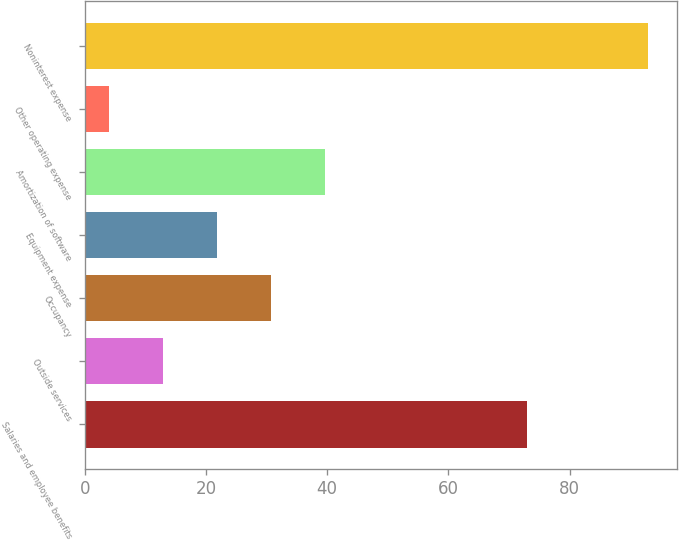Convert chart to OTSL. <chart><loc_0><loc_0><loc_500><loc_500><bar_chart><fcel>Salaries and employee benefits<fcel>Outside services<fcel>Occupancy<fcel>Equipment expense<fcel>Amortization of software<fcel>Other operating expense<fcel>Noninterest expense<nl><fcel>73<fcel>12.9<fcel>30.7<fcel>21.8<fcel>39.6<fcel>4<fcel>93<nl></chart> 